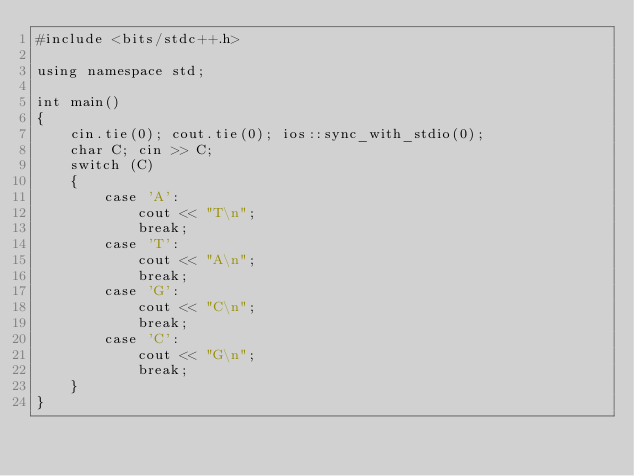Convert code to text. <code><loc_0><loc_0><loc_500><loc_500><_C++_>#include <bits/stdc++.h>

using namespace std;

int main()
{
    cin.tie(0); cout.tie(0); ios::sync_with_stdio(0);
    char C; cin >> C;
    switch (C)
    {
        case 'A':
            cout << "T\n";
            break;
        case 'T':
            cout << "A\n";
            break;
        case 'G':
            cout << "C\n";
            break;
        case 'C':
            cout << "G\n";
            break;
    }
}</code> 